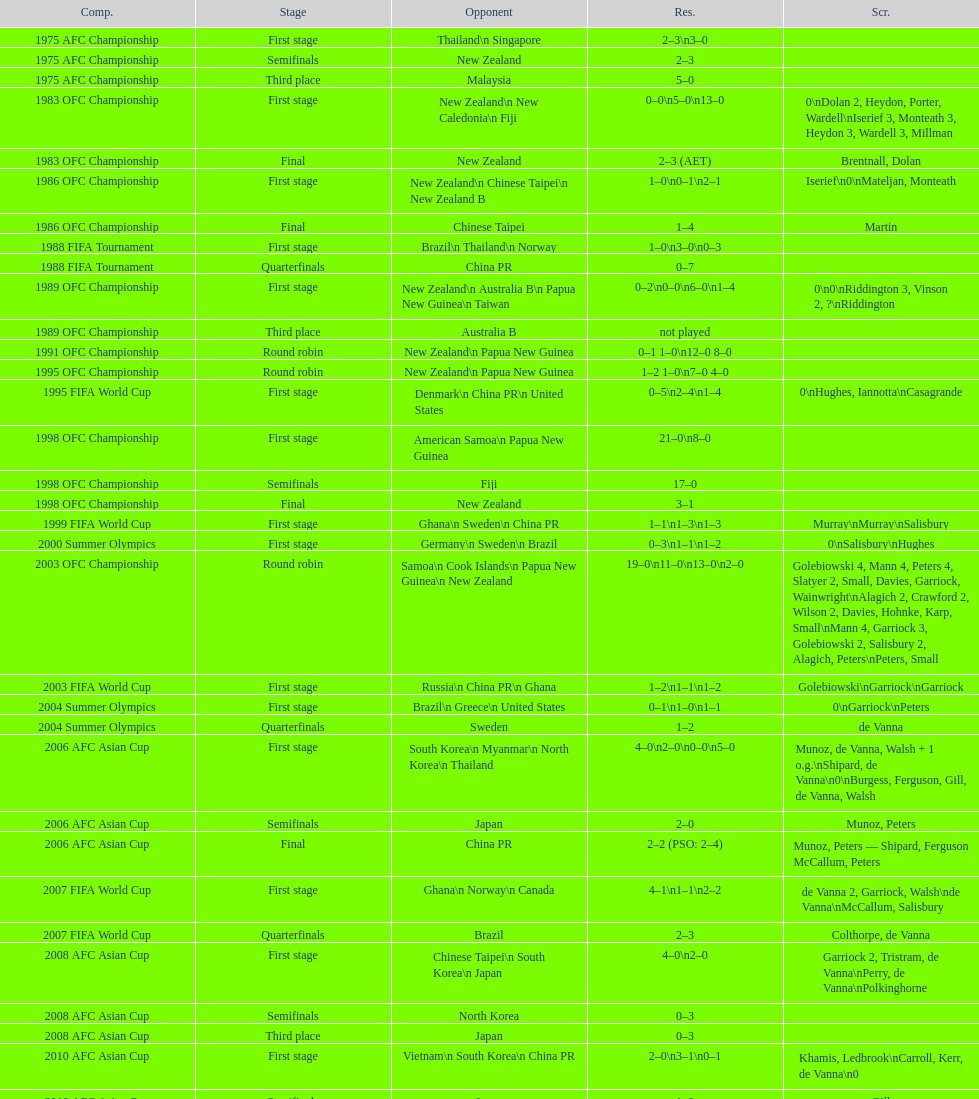What is the total number of competitions? 21. 